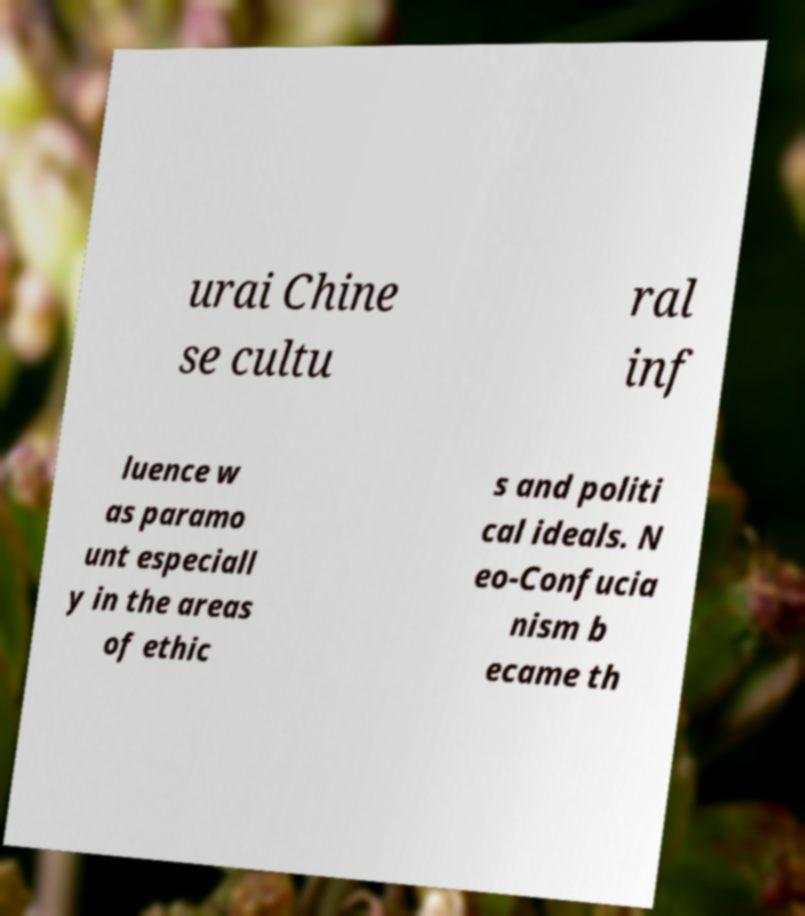There's text embedded in this image that I need extracted. Can you transcribe it verbatim? urai Chine se cultu ral inf luence w as paramo unt especiall y in the areas of ethic s and politi cal ideals. N eo-Confucia nism b ecame th 